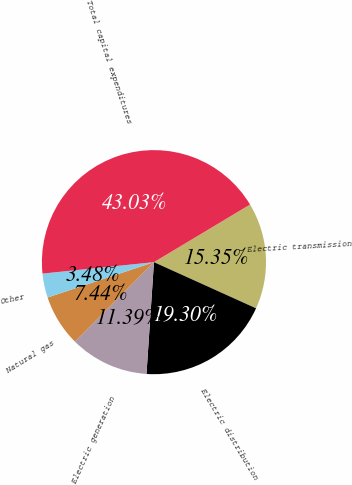Convert chart. <chart><loc_0><loc_0><loc_500><loc_500><pie_chart><fcel>Electric transmission<fcel>Electric distribution<fcel>Electric generation<fcel>Natural gas<fcel>Other<fcel>Total capital expenditures<nl><fcel>15.35%<fcel>19.3%<fcel>11.39%<fcel>7.44%<fcel>3.48%<fcel>43.03%<nl></chart> 